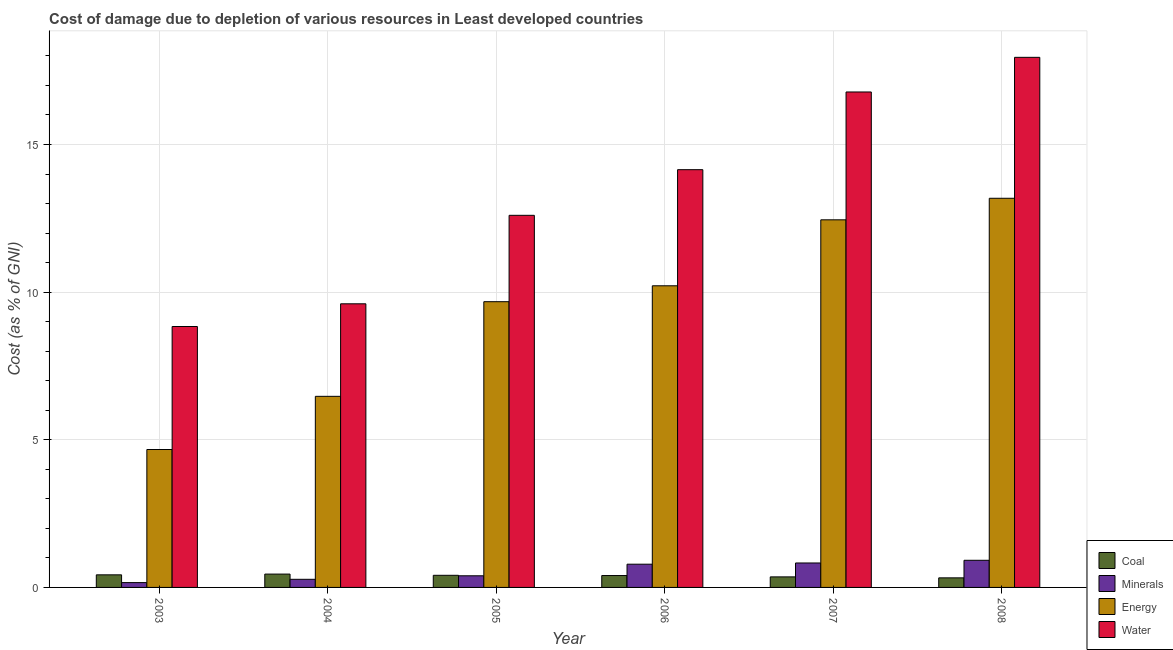How many different coloured bars are there?
Offer a very short reply. 4. What is the cost of damage due to depletion of coal in 2004?
Give a very brief answer. 0.45. Across all years, what is the maximum cost of damage due to depletion of energy?
Keep it short and to the point. 13.18. Across all years, what is the minimum cost of damage due to depletion of water?
Offer a very short reply. 8.84. In which year was the cost of damage due to depletion of minerals maximum?
Your answer should be compact. 2008. In which year was the cost of damage due to depletion of energy minimum?
Offer a terse response. 2003. What is the total cost of damage due to depletion of water in the graph?
Your answer should be compact. 79.92. What is the difference between the cost of damage due to depletion of water in 2003 and that in 2006?
Keep it short and to the point. -5.31. What is the difference between the cost of damage due to depletion of coal in 2008 and the cost of damage due to depletion of energy in 2006?
Provide a succinct answer. -0.08. What is the average cost of damage due to depletion of coal per year?
Ensure brevity in your answer.  0.4. What is the ratio of the cost of damage due to depletion of water in 2003 to that in 2005?
Your response must be concise. 0.7. Is the difference between the cost of damage due to depletion of water in 2004 and 2005 greater than the difference between the cost of damage due to depletion of coal in 2004 and 2005?
Keep it short and to the point. No. What is the difference between the highest and the second highest cost of damage due to depletion of coal?
Provide a succinct answer. 0.03. What is the difference between the highest and the lowest cost of damage due to depletion of coal?
Provide a succinct answer. 0.13. In how many years, is the cost of damage due to depletion of energy greater than the average cost of damage due to depletion of energy taken over all years?
Provide a short and direct response. 4. What does the 1st bar from the left in 2008 represents?
Offer a very short reply. Coal. What does the 2nd bar from the right in 2007 represents?
Make the answer very short. Energy. Is it the case that in every year, the sum of the cost of damage due to depletion of coal and cost of damage due to depletion of minerals is greater than the cost of damage due to depletion of energy?
Your answer should be compact. No. How many years are there in the graph?
Give a very brief answer. 6. Are the values on the major ticks of Y-axis written in scientific E-notation?
Keep it short and to the point. No. Where does the legend appear in the graph?
Offer a very short reply. Bottom right. How many legend labels are there?
Your answer should be very brief. 4. How are the legend labels stacked?
Ensure brevity in your answer.  Vertical. What is the title of the graph?
Your response must be concise. Cost of damage due to depletion of various resources in Least developed countries . What is the label or title of the X-axis?
Ensure brevity in your answer.  Year. What is the label or title of the Y-axis?
Ensure brevity in your answer.  Cost (as % of GNI). What is the Cost (as % of GNI) in Coal in 2003?
Provide a succinct answer. 0.43. What is the Cost (as % of GNI) of Minerals in 2003?
Your response must be concise. 0.16. What is the Cost (as % of GNI) of Energy in 2003?
Make the answer very short. 4.67. What is the Cost (as % of GNI) of Water in 2003?
Provide a succinct answer. 8.84. What is the Cost (as % of GNI) of Coal in 2004?
Offer a terse response. 0.45. What is the Cost (as % of GNI) of Minerals in 2004?
Keep it short and to the point. 0.27. What is the Cost (as % of GNI) of Energy in 2004?
Your answer should be compact. 6.47. What is the Cost (as % of GNI) in Water in 2004?
Offer a terse response. 9.61. What is the Cost (as % of GNI) in Coal in 2005?
Ensure brevity in your answer.  0.41. What is the Cost (as % of GNI) in Minerals in 2005?
Offer a terse response. 0.39. What is the Cost (as % of GNI) in Energy in 2005?
Ensure brevity in your answer.  9.68. What is the Cost (as % of GNI) in Water in 2005?
Give a very brief answer. 12.6. What is the Cost (as % of GNI) in Coal in 2006?
Offer a terse response. 0.4. What is the Cost (as % of GNI) of Minerals in 2006?
Offer a very short reply. 0.79. What is the Cost (as % of GNI) in Energy in 2006?
Your response must be concise. 10.22. What is the Cost (as % of GNI) in Water in 2006?
Your response must be concise. 14.15. What is the Cost (as % of GNI) of Coal in 2007?
Provide a short and direct response. 0.36. What is the Cost (as % of GNI) in Minerals in 2007?
Give a very brief answer. 0.83. What is the Cost (as % of GNI) of Energy in 2007?
Ensure brevity in your answer.  12.45. What is the Cost (as % of GNI) in Water in 2007?
Offer a very short reply. 16.78. What is the Cost (as % of GNI) in Coal in 2008?
Keep it short and to the point. 0.32. What is the Cost (as % of GNI) in Minerals in 2008?
Give a very brief answer. 0.92. What is the Cost (as % of GNI) in Energy in 2008?
Make the answer very short. 13.18. What is the Cost (as % of GNI) in Water in 2008?
Offer a terse response. 17.95. Across all years, what is the maximum Cost (as % of GNI) in Coal?
Your answer should be compact. 0.45. Across all years, what is the maximum Cost (as % of GNI) in Minerals?
Keep it short and to the point. 0.92. Across all years, what is the maximum Cost (as % of GNI) of Energy?
Your response must be concise. 13.18. Across all years, what is the maximum Cost (as % of GNI) in Water?
Offer a terse response. 17.95. Across all years, what is the minimum Cost (as % of GNI) of Coal?
Your answer should be compact. 0.32. Across all years, what is the minimum Cost (as % of GNI) of Minerals?
Offer a terse response. 0.16. Across all years, what is the minimum Cost (as % of GNI) in Energy?
Give a very brief answer. 4.67. Across all years, what is the minimum Cost (as % of GNI) in Water?
Your answer should be compact. 8.84. What is the total Cost (as % of GNI) of Coal in the graph?
Offer a terse response. 2.37. What is the total Cost (as % of GNI) of Minerals in the graph?
Your response must be concise. 3.37. What is the total Cost (as % of GNI) in Energy in the graph?
Your answer should be compact. 56.66. What is the total Cost (as % of GNI) in Water in the graph?
Your answer should be very brief. 79.92. What is the difference between the Cost (as % of GNI) in Coal in 2003 and that in 2004?
Your response must be concise. -0.03. What is the difference between the Cost (as % of GNI) of Minerals in 2003 and that in 2004?
Your answer should be compact. -0.11. What is the difference between the Cost (as % of GNI) in Energy in 2003 and that in 2004?
Make the answer very short. -1.8. What is the difference between the Cost (as % of GNI) in Water in 2003 and that in 2004?
Ensure brevity in your answer.  -0.77. What is the difference between the Cost (as % of GNI) of Coal in 2003 and that in 2005?
Offer a terse response. 0.02. What is the difference between the Cost (as % of GNI) of Minerals in 2003 and that in 2005?
Your response must be concise. -0.23. What is the difference between the Cost (as % of GNI) in Energy in 2003 and that in 2005?
Provide a short and direct response. -5.01. What is the difference between the Cost (as % of GNI) of Water in 2003 and that in 2005?
Keep it short and to the point. -3.77. What is the difference between the Cost (as % of GNI) in Coal in 2003 and that in 2006?
Give a very brief answer. 0.02. What is the difference between the Cost (as % of GNI) in Minerals in 2003 and that in 2006?
Your answer should be compact. -0.62. What is the difference between the Cost (as % of GNI) in Energy in 2003 and that in 2006?
Your answer should be compact. -5.54. What is the difference between the Cost (as % of GNI) in Water in 2003 and that in 2006?
Offer a terse response. -5.31. What is the difference between the Cost (as % of GNI) of Coal in 2003 and that in 2007?
Your response must be concise. 0.07. What is the difference between the Cost (as % of GNI) in Minerals in 2003 and that in 2007?
Provide a short and direct response. -0.66. What is the difference between the Cost (as % of GNI) in Energy in 2003 and that in 2007?
Provide a short and direct response. -7.78. What is the difference between the Cost (as % of GNI) of Water in 2003 and that in 2007?
Offer a terse response. -7.94. What is the difference between the Cost (as % of GNI) of Coal in 2003 and that in 2008?
Offer a very short reply. 0.1. What is the difference between the Cost (as % of GNI) of Minerals in 2003 and that in 2008?
Make the answer very short. -0.76. What is the difference between the Cost (as % of GNI) in Energy in 2003 and that in 2008?
Keep it short and to the point. -8.51. What is the difference between the Cost (as % of GNI) in Water in 2003 and that in 2008?
Make the answer very short. -9.12. What is the difference between the Cost (as % of GNI) of Coal in 2004 and that in 2005?
Offer a very short reply. 0.04. What is the difference between the Cost (as % of GNI) in Minerals in 2004 and that in 2005?
Make the answer very short. -0.12. What is the difference between the Cost (as % of GNI) of Energy in 2004 and that in 2005?
Your answer should be very brief. -3.21. What is the difference between the Cost (as % of GNI) in Water in 2004 and that in 2005?
Your answer should be compact. -3. What is the difference between the Cost (as % of GNI) in Coal in 2004 and that in 2006?
Offer a very short reply. 0.05. What is the difference between the Cost (as % of GNI) in Minerals in 2004 and that in 2006?
Your answer should be compact. -0.51. What is the difference between the Cost (as % of GNI) of Energy in 2004 and that in 2006?
Make the answer very short. -3.74. What is the difference between the Cost (as % of GNI) in Water in 2004 and that in 2006?
Your response must be concise. -4.54. What is the difference between the Cost (as % of GNI) in Coal in 2004 and that in 2007?
Keep it short and to the point. 0.09. What is the difference between the Cost (as % of GNI) of Minerals in 2004 and that in 2007?
Your response must be concise. -0.55. What is the difference between the Cost (as % of GNI) in Energy in 2004 and that in 2007?
Give a very brief answer. -5.98. What is the difference between the Cost (as % of GNI) in Water in 2004 and that in 2007?
Provide a succinct answer. -7.17. What is the difference between the Cost (as % of GNI) of Coal in 2004 and that in 2008?
Offer a terse response. 0.13. What is the difference between the Cost (as % of GNI) in Minerals in 2004 and that in 2008?
Your response must be concise. -0.64. What is the difference between the Cost (as % of GNI) in Energy in 2004 and that in 2008?
Provide a succinct answer. -6.71. What is the difference between the Cost (as % of GNI) of Water in 2004 and that in 2008?
Make the answer very short. -8.35. What is the difference between the Cost (as % of GNI) in Coal in 2005 and that in 2006?
Your answer should be very brief. 0.01. What is the difference between the Cost (as % of GNI) of Minerals in 2005 and that in 2006?
Ensure brevity in your answer.  -0.39. What is the difference between the Cost (as % of GNI) of Energy in 2005 and that in 2006?
Your answer should be very brief. -0.54. What is the difference between the Cost (as % of GNI) of Water in 2005 and that in 2006?
Provide a succinct answer. -1.55. What is the difference between the Cost (as % of GNI) in Coal in 2005 and that in 2007?
Your response must be concise. 0.05. What is the difference between the Cost (as % of GNI) in Minerals in 2005 and that in 2007?
Your response must be concise. -0.43. What is the difference between the Cost (as % of GNI) in Energy in 2005 and that in 2007?
Offer a very short reply. -2.77. What is the difference between the Cost (as % of GNI) of Water in 2005 and that in 2007?
Make the answer very short. -4.18. What is the difference between the Cost (as % of GNI) of Coal in 2005 and that in 2008?
Make the answer very short. 0.09. What is the difference between the Cost (as % of GNI) in Minerals in 2005 and that in 2008?
Your answer should be very brief. -0.53. What is the difference between the Cost (as % of GNI) of Energy in 2005 and that in 2008?
Ensure brevity in your answer.  -3.5. What is the difference between the Cost (as % of GNI) of Water in 2005 and that in 2008?
Your answer should be very brief. -5.35. What is the difference between the Cost (as % of GNI) in Coal in 2006 and that in 2007?
Provide a short and direct response. 0.05. What is the difference between the Cost (as % of GNI) in Minerals in 2006 and that in 2007?
Provide a short and direct response. -0.04. What is the difference between the Cost (as % of GNI) in Energy in 2006 and that in 2007?
Give a very brief answer. -2.23. What is the difference between the Cost (as % of GNI) in Water in 2006 and that in 2007?
Ensure brevity in your answer.  -2.63. What is the difference between the Cost (as % of GNI) in Coal in 2006 and that in 2008?
Your answer should be very brief. 0.08. What is the difference between the Cost (as % of GNI) of Minerals in 2006 and that in 2008?
Ensure brevity in your answer.  -0.13. What is the difference between the Cost (as % of GNI) of Energy in 2006 and that in 2008?
Offer a very short reply. -2.96. What is the difference between the Cost (as % of GNI) in Water in 2006 and that in 2008?
Provide a short and direct response. -3.81. What is the difference between the Cost (as % of GNI) in Coal in 2007 and that in 2008?
Your answer should be compact. 0.03. What is the difference between the Cost (as % of GNI) of Minerals in 2007 and that in 2008?
Offer a terse response. -0.09. What is the difference between the Cost (as % of GNI) in Energy in 2007 and that in 2008?
Keep it short and to the point. -0.73. What is the difference between the Cost (as % of GNI) in Water in 2007 and that in 2008?
Make the answer very short. -1.17. What is the difference between the Cost (as % of GNI) of Coal in 2003 and the Cost (as % of GNI) of Minerals in 2004?
Make the answer very short. 0.15. What is the difference between the Cost (as % of GNI) of Coal in 2003 and the Cost (as % of GNI) of Energy in 2004?
Provide a succinct answer. -6.05. What is the difference between the Cost (as % of GNI) of Coal in 2003 and the Cost (as % of GNI) of Water in 2004?
Provide a succinct answer. -9.18. What is the difference between the Cost (as % of GNI) of Minerals in 2003 and the Cost (as % of GNI) of Energy in 2004?
Your response must be concise. -6.31. What is the difference between the Cost (as % of GNI) of Minerals in 2003 and the Cost (as % of GNI) of Water in 2004?
Ensure brevity in your answer.  -9.44. What is the difference between the Cost (as % of GNI) in Energy in 2003 and the Cost (as % of GNI) in Water in 2004?
Offer a very short reply. -4.93. What is the difference between the Cost (as % of GNI) of Coal in 2003 and the Cost (as % of GNI) of Minerals in 2005?
Your response must be concise. 0.03. What is the difference between the Cost (as % of GNI) in Coal in 2003 and the Cost (as % of GNI) in Energy in 2005?
Offer a terse response. -9.25. What is the difference between the Cost (as % of GNI) in Coal in 2003 and the Cost (as % of GNI) in Water in 2005?
Your answer should be very brief. -12.18. What is the difference between the Cost (as % of GNI) in Minerals in 2003 and the Cost (as % of GNI) in Energy in 2005?
Your response must be concise. -9.51. What is the difference between the Cost (as % of GNI) in Minerals in 2003 and the Cost (as % of GNI) in Water in 2005?
Keep it short and to the point. -12.44. What is the difference between the Cost (as % of GNI) of Energy in 2003 and the Cost (as % of GNI) of Water in 2005?
Provide a short and direct response. -7.93. What is the difference between the Cost (as % of GNI) of Coal in 2003 and the Cost (as % of GNI) of Minerals in 2006?
Your response must be concise. -0.36. What is the difference between the Cost (as % of GNI) in Coal in 2003 and the Cost (as % of GNI) in Energy in 2006?
Offer a very short reply. -9.79. What is the difference between the Cost (as % of GNI) in Coal in 2003 and the Cost (as % of GNI) in Water in 2006?
Ensure brevity in your answer.  -13.72. What is the difference between the Cost (as % of GNI) of Minerals in 2003 and the Cost (as % of GNI) of Energy in 2006?
Your response must be concise. -10.05. What is the difference between the Cost (as % of GNI) in Minerals in 2003 and the Cost (as % of GNI) in Water in 2006?
Your answer should be very brief. -13.98. What is the difference between the Cost (as % of GNI) in Energy in 2003 and the Cost (as % of GNI) in Water in 2006?
Make the answer very short. -9.48. What is the difference between the Cost (as % of GNI) of Coal in 2003 and the Cost (as % of GNI) of Minerals in 2007?
Your answer should be compact. -0.4. What is the difference between the Cost (as % of GNI) of Coal in 2003 and the Cost (as % of GNI) of Energy in 2007?
Give a very brief answer. -12.02. What is the difference between the Cost (as % of GNI) in Coal in 2003 and the Cost (as % of GNI) in Water in 2007?
Your answer should be compact. -16.35. What is the difference between the Cost (as % of GNI) in Minerals in 2003 and the Cost (as % of GNI) in Energy in 2007?
Provide a succinct answer. -12.29. What is the difference between the Cost (as % of GNI) in Minerals in 2003 and the Cost (as % of GNI) in Water in 2007?
Make the answer very short. -16.62. What is the difference between the Cost (as % of GNI) of Energy in 2003 and the Cost (as % of GNI) of Water in 2007?
Offer a very short reply. -12.11. What is the difference between the Cost (as % of GNI) of Coal in 2003 and the Cost (as % of GNI) of Minerals in 2008?
Provide a succinct answer. -0.49. What is the difference between the Cost (as % of GNI) in Coal in 2003 and the Cost (as % of GNI) in Energy in 2008?
Offer a very short reply. -12.75. What is the difference between the Cost (as % of GNI) in Coal in 2003 and the Cost (as % of GNI) in Water in 2008?
Offer a very short reply. -17.53. What is the difference between the Cost (as % of GNI) of Minerals in 2003 and the Cost (as % of GNI) of Energy in 2008?
Your answer should be compact. -13.02. What is the difference between the Cost (as % of GNI) of Minerals in 2003 and the Cost (as % of GNI) of Water in 2008?
Offer a terse response. -17.79. What is the difference between the Cost (as % of GNI) of Energy in 2003 and the Cost (as % of GNI) of Water in 2008?
Provide a short and direct response. -13.28. What is the difference between the Cost (as % of GNI) of Coal in 2004 and the Cost (as % of GNI) of Minerals in 2005?
Keep it short and to the point. 0.06. What is the difference between the Cost (as % of GNI) in Coal in 2004 and the Cost (as % of GNI) in Energy in 2005?
Provide a succinct answer. -9.23. What is the difference between the Cost (as % of GNI) in Coal in 2004 and the Cost (as % of GNI) in Water in 2005?
Give a very brief answer. -12.15. What is the difference between the Cost (as % of GNI) of Minerals in 2004 and the Cost (as % of GNI) of Energy in 2005?
Your response must be concise. -9.4. What is the difference between the Cost (as % of GNI) of Minerals in 2004 and the Cost (as % of GNI) of Water in 2005?
Make the answer very short. -12.33. What is the difference between the Cost (as % of GNI) of Energy in 2004 and the Cost (as % of GNI) of Water in 2005?
Ensure brevity in your answer.  -6.13. What is the difference between the Cost (as % of GNI) of Coal in 2004 and the Cost (as % of GNI) of Minerals in 2006?
Keep it short and to the point. -0.33. What is the difference between the Cost (as % of GNI) in Coal in 2004 and the Cost (as % of GNI) in Energy in 2006?
Your answer should be very brief. -9.76. What is the difference between the Cost (as % of GNI) of Coal in 2004 and the Cost (as % of GNI) of Water in 2006?
Provide a succinct answer. -13.7. What is the difference between the Cost (as % of GNI) in Minerals in 2004 and the Cost (as % of GNI) in Energy in 2006?
Make the answer very short. -9.94. What is the difference between the Cost (as % of GNI) in Minerals in 2004 and the Cost (as % of GNI) in Water in 2006?
Ensure brevity in your answer.  -13.87. What is the difference between the Cost (as % of GNI) of Energy in 2004 and the Cost (as % of GNI) of Water in 2006?
Give a very brief answer. -7.68. What is the difference between the Cost (as % of GNI) of Coal in 2004 and the Cost (as % of GNI) of Minerals in 2007?
Ensure brevity in your answer.  -0.38. What is the difference between the Cost (as % of GNI) in Coal in 2004 and the Cost (as % of GNI) in Energy in 2007?
Give a very brief answer. -12. What is the difference between the Cost (as % of GNI) of Coal in 2004 and the Cost (as % of GNI) of Water in 2007?
Give a very brief answer. -16.33. What is the difference between the Cost (as % of GNI) in Minerals in 2004 and the Cost (as % of GNI) in Energy in 2007?
Offer a terse response. -12.17. What is the difference between the Cost (as % of GNI) in Minerals in 2004 and the Cost (as % of GNI) in Water in 2007?
Provide a succinct answer. -16.5. What is the difference between the Cost (as % of GNI) of Energy in 2004 and the Cost (as % of GNI) of Water in 2007?
Give a very brief answer. -10.31. What is the difference between the Cost (as % of GNI) in Coal in 2004 and the Cost (as % of GNI) in Minerals in 2008?
Offer a terse response. -0.47. What is the difference between the Cost (as % of GNI) of Coal in 2004 and the Cost (as % of GNI) of Energy in 2008?
Your response must be concise. -12.73. What is the difference between the Cost (as % of GNI) of Coal in 2004 and the Cost (as % of GNI) of Water in 2008?
Keep it short and to the point. -17.5. What is the difference between the Cost (as % of GNI) of Minerals in 2004 and the Cost (as % of GNI) of Energy in 2008?
Your response must be concise. -12.9. What is the difference between the Cost (as % of GNI) in Minerals in 2004 and the Cost (as % of GNI) in Water in 2008?
Provide a short and direct response. -17.68. What is the difference between the Cost (as % of GNI) in Energy in 2004 and the Cost (as % of GNI) in Water in 2008?
Offer a terse response. -11.48. What is the difference between the Cost (as % of GNI) of Coal in 2005 and the Cost (as % of GNI) of Minerals in 2006?
Your response must be concise. -0.38. What is the difference between the Cost (as % of GNI) of Coal in 2005 and the Cost (as % of GNI) of Energy in 2006?
Keep it short and to the point. -9.81. What is the difference between the Cost (as % of GNI) of Coal in 2005 and the Cost (as % of GNI) of Water in 2006?
Your answer should be compact. -13.74. What is the difference between the Cost (as % of GNI) of Minerals in 2005 and the Cost (as % of GNI) of Energy in 2006?
Keep it short and to the point. -9.82. What is the difference between the Cost (as % of GNI) of Minerals in 2005 and the Cost (as % of GNI) of Water in 2006?
Keep it short and to the point. -13.75. What is the difference between the Cost (as % of GNI) of Energy in 2005 and the Cost (as % of GNI) of Water in 2006?
Make the answer very short. -4.47. What is the difference between the Cost (as % of GNI) of Coal in 2005 and the Cost (as % of GNI) of Minerals in 2007?
Keep it short and to the point. -0.42. What is the difference between the Cost (as % of GNI) of Coal in 2005 and the Cost (as % of GNI) of Energy in 2007?
Ensure brevity in your answer.  -12.04. What is the difference between the Cost (as % of GNI) in Coal in 2005 and the Cost (as % of GNI) in Water in 2007?
Give a very brief answer. -16.37. What is the difference between the Cost (as % of GNI) in Minerals in 2005 and the Cost (as % of GNI) in Energy in 2007?
Provide a succinct answer. -12.06. What is the difference between the Cost (as % of GNI) in Minerals in 2005 and the Cost (as % of GNI) in Water in 2007?
Make the answer very short. -16.39. What is the difference between the Cost (as % of GNI) of Energy in 2005 and the Cost (as % of GNI) of Water in 2007?
Offer a very short reply. -7.1. What is the difference between the Cost (as % of GNI) of Coal in 2005 and the Cost (as % of GNI) of Minerals in 2008?
Provide a short and direct response. -0.51. What is the difference between the Cost (as % of GNI) of Coal in 2005 and the Cost (as % of GNI) of Energy in 2008?
Your response must be concise. -12.77. What is the difference between the Cost (as % of GNI) in Coal in 2005 and the Cost (as % of GNI) in Water in 2008?
Offer a very short reply. -17.54. What is the difference between the Cost (as % of GNI) in Minerals in 2005 and the Cost (as % of GNI) in Energy in 2008?
Provide a succinct answer. -12.79. What is the difference between the Cost (as % of GNI) in Minerals in 2005 and the Cost (as % of GNI) in Water in 2008?
Provide a short and direct response. -17.56. What is the difference between the Cost (as % of GNI) of Energy in 2005 and the Cost (as % of GNI) of Water in 2008?
Your answer should be compact. -8.28. What is the difference between the Cost (as % of GNI) of Coal in 2006 and the Cost (as % of GNI) of Minerals in 2007?
Your response must be concise. -0.43. What is the difference between the Cost (as % of GNI) in Coal in 2006 and the Cost (as % of GNI) in Energy in 2007?
Offer a very short reply. -12.05. What is the difference between the Cost (as % of GNI) in Coal in 2006 and the Cost (as % of GNI) in Water in 2007?
Your answer should be very brief. -16.38. What is the difference between the Cost (as % of GNI) in Minerals in 2006 and the Cost (as % of GNI) in Energy in 2007?
Make the answer very short. -11.66. What is the difference between the Cost (as % of GNI) of Minerals in 2006 and the Cost (as % of GNI) of Water in 2007?
Provide a succinct answer. -15.99. What is the difference between the Cost (as % of GNI) of Energy in 2006 and the Cost (as % of GNI) of Water in 2007?
Your response must be concise. -6.56. What is the difference between the Cost (as % of GNI) in Coal in 2006 and the Cost (as % of GNI) in Minerals in 2008?
Offer a very short reply. -0.52. What is the difference between the Cost (as % of GNI) in Coal in 2006 and the Cost (as % of GNI) in Energy in 2008?
Offer a very short reply. -12.78. What is the difference between the Cost (as % of GNI) in Coal in 2006 and the Cost (as % of GNI) in Water in 2008?
Your answer should be very brief. -17.55. What is the difference between the Cost (as % of GNI) of Minerals in 2006 and the Cost (as % of GNI) of Energy in 2008?
Provide a short and direct response. -12.39. What is the difference between the Cost (as % of GNI) in Minerals in 2006 and the Cost (as % of GNI) in Water in 2008?
Your answer should be very brief. -17.17. What is the difference between the Cost (as % of GNI) in Energy in 2006 and the Cost (as % of GNI) in Water in 2008?
Ensure brevity in your answer.  -7.74. What is the difference between the Cost (as % of GNI) in Coal in 2007 and the Cost (as % of GNI) in Minerals in 2008?
Your response must be concise. -0.56. What is the difference between the Cost (as % of GNI) in Coal in 2007 and the Cost (as % of GNI) in Energy in 2008?
Your response must be concise. -12.82. What is the difference between the Cost (as % of GNI) of Coal in 2007 and the Cost (as % of GNI) of Water in 2008?
Offer a terse response. -17.6. What is the difference between the Cost (as % of GNI) in Minerals in 2007 and the Cost (as % of GNI) in Energy in 2008?
Your response must be concise. -12.35. What is the difference between the Cost (as % of GNI) of Minerals in 2007 and the Cost (as % of GNI) of Water in 2008?
Your response must be concise. -17.12. What is the difference between the Cost (as % of GNI) of Energy in 2007 and the Cost (as % of GNI) of Water in 2008?
Make the answer very short. -5.5. What is the average Cost (as % of GNI) in Coal per year?
Your answer should be compact. 0.4. What is the average Cost (as % of GNI) of Minerals per year?
Offer a terse response. 0.56. What is the average Cost (as % of GNI) in Energy per year?
Give a very brief answer. 9.44. What is the average Cost (as % of GNI) of Water per year?
Your answer should be compact. 13.32. In the year 2003, what is the difference between the Cost (as % of GNI) of Coal and Cost (as % of GNI) of Minerals?
Ensure brevity in your answer.  0.26. In the year 2003, what is the difference between the Cost (as % of GNI) of Coal and Cost (as % of GNI) of Energy?
Provide a succinct answer. -4.24. In the year 2003, what is the difference between the Cost (as % of GNI) of Coal and Cost (as % of GNI) of Water?
Provide a succinct answer. -8.41. In the year 2003, what is the difference between the Cost (as % of GNI) of Minerals and Cost (as % of GNI) of Energy?
Your answer should be very brief. -4.51. In the year 2003, what is the difference between the Cost (as % of GNI) of Minerals and Cost (as % of GNI) of Water?
Offer a terse response. -8.67. In the year 2003, what is the difference between the Cost (as % of GNI) in Energy and Cost (as % of GNI) in Water?
Give a very brief answer. -4.17. In the year 2004, what is the difference between the Cost (as % of GNI) of Coal and Cost (as % of GNI) of Minerals?
Give a very brief answer. 0.18. In the year 2004, what is the difference between the Cost (as % of GNI) in Coal and Cost (as % of GNI) in Energy?
Your answer should be very brief. -6.02. In the year 2004, what is the difference between the Cost (as % of GNI) in Coal and Cost (as % of GNI) in Water?
Ensure brevity in your answer.  -9.15. In the year 2004, what is the difference between the Cost (as % of GNI) in Minerals and Cost (as % of GNI) in Energy?
Make the answer very short. -6.2. In the year 2004, what is the difference between the Cost (as % of GNI) in Minerals and Cost (as % of GNI) in Water?
Ensure brevity in your answer.  -9.33. In the year 2004, what is the difference between the Cost (as % of GNI) of Energy and Cost (as % of GNI) of Water?
Provide a short and direct response. -3.13. In the year 2005, what is the difference between the Cost (as % of GNI) in Coal and Cost (as % of GNI) in Minerals?
Make the answer very short. 0.02. In the year 2005, what is the difference between the Cost (as % of GNI) in Coal and Cost (as % of GNI) in Energy?
Provide a succinct answer. -9.27. In the year 2005, what is the difference between the Cost (as % of GNI) in Coal and Cost (as % of GNI) in Water?
Provide a succinct answer. -12.19. In the year 2005, what is the difference between the Cost (as % of GNI) of Minerals and Cost (as % of GNI) of Energy?
Offer a terse response. -9.28. In the year 2005, what is the difference between the Cost (as % of GNI) in Minerals and Cost (as % of GNI) in Water?
Make the answer very short. -12.21. In the year 2005, what is the difference between the Cost (as % of GNI) of Energy and Cost (as % of GNI) of Water?
Your answer should be very brief. -2.92. In the year 2006, what is the difference between the Cost (as % of GNI) in Coal and Cost (as % of GNI) in Minerals?
Provide a succinct answer. -0.38. In the year 2006, what is the difference between the Cost (as % of GNI) in Coal and Cost (as % of GNI) in Energy?
Your answer should be compact. -9.81. In the year 2006, what is the difference between the Cost (as % of GNI) in Coal and Cost (as % of GNI) in Water?
Ensure brevity in your answer.  -13.75. In the year 2006, what is the difference between the Cost (as % of GNI) of Minerals and Cost (as % of GNI) of Energy?
Your answer should be very brief. -9.43. In the year 2006, what is the difference between the Cost (as % of GNI) in Minerals and Cost (as % of GNI) in Water?
Provide a short and direct response. -13.36. In the year 2006, what is the difference between the Cost (as % of GNI) of Energy and Cost (as % of GNI) of Water?
Your answer should be very brief. -3.93. In the year 2007, what is the difference between the Cost (as % of GNI) in Coal and Cost (as % of GNI) in Minerals?
Your answer should be very brief. -0.47. In the year 2007, what is the difference between the Cost (as % of GNI) in Coal and Cost (as % of GNI) in Energy?
Ensure brevity in your answer.  -12.09. In the year 2007, what is the difference between the Cost (as % of GNI) in Coal and Cost (as % of GNI) in Water?
Provide a short and direct response. -16.42. In the year 2007, what is the difference between the Cost (as % of GNI) in Minerals and Cost (as % of GNI) in Energy?
Make the answer very short. -11.62. In the year 2007, what is the difference between the Cost (as % of GNI) of Minerals and Cost (as % of GNI) of Water?
Ensure brevity in your answer.  -15.95. In the year 2007, what is the difference between the Cost (as % of GNI) in Energy and Cost (as % of GNI) in Water?
Keep it short and to the point. -4.33. In the year 2008, what is the difference between the Cost (as % of GNI) in Coal and Cost (as % of GNI) in Minerals?
Provide a short and direct response. -0.59. In the year 2008, what is the difference between the Cost (as % of GNI) in Coal and Cost (as % of GNI) in Energy?
Your response must be concise. -12.86. In the year 2008, what is the difference between the Cost (as % of GNI) in Coal and Cost (as % of GNI) in Water?
Keep it short and to the point. -17.63. In the year 2008, what is the difference between the Cost (as % of GNI) in Minerals and Cost (as % of GNI) in Energy?
Keep it short and to the point. -12.26. In the year 2008, what is the difference between the Cost (as % of GNI) of Minerals and Cost (as % of GNI) of Water?
Your answer should be compact. -17.03. In the year 2008, what is the difference between the Cost (as % of GNI) in Energy and Cost (as % of GNI) in Water?
Give a very brief answer. -4.77. What is the ratio of the Cost (as % of GNI) of Coal in 2003 to that in 2004?
Offer a very short reply. 0.94. What is the ratio of the Cost (as % of GNI) of Minerals in 2003 to that in 2004?
Your answer should be compact. 0.59. What is the ratio of the Cost (as % of GNI) in Energy in 2003 to that in 2004?
Make the answer very short. 0.72. What is the ratio of the Cost (as % of GNI) in Water in 2003 to that in 2004?
Your response must be concise. 0.92. What is the ratio of the Cost (as % of GNI) of Coal in 2003 to that in 2005?
Make the answer very short. 1.04. What is the ratio of the Cost (as % of GNI) of Minerals in 2003 to that in 2005?
Keep it short and to the point. 0.41. What is the ratio of the Cost (as % of GNI) in Energy in 2003 to that in 2005?
Keep it short and to the point. 0.48. What is the ratio of the Cost (as % of GNI) of Water in 2003 to that in 2005?
Ensure brevity in your answer.  0.7. What is the ratio of the Cost (as % of GNI) of Coal in 2003 to that in 2006?
Ensure brevity in your answer.  1.06. What is the ratio of the Cost (as % of GNI) in Minerals in 2003 to that in 2006?
Make the answer very short. 0.21. What is the ratio of the Cost (as % of GNI) of Energy in 2003 to that in 2006?
Provide a short and direct response. 0.46. What is the ratio of the Cost (as % of GNI) in Water in 2003 to that in 2006?
Your answer should be very brief. 0.62. What is the ratio of the Cost (as % of GNI) in Coal in 2003 to that in 2007?
Keep it short and to the point. 1.19. What is the ratio of the Cost (as % of GNI) of Minerals in 2003 to that in 2007?
Your response must be concise. 0.2. What is the ratio of the Cost (as % of GNI) of Energy in 2003 to that in 2007?
Offer a very short reply. 0.38. What is the ratio of the Cost (as % of GNI) in Water in 2003 to that in 2007?
Your answer should be compact. 0.53. What is the ratio of the Cost (as % of GNI) of Coal in 2003 to that in 2008?
Keep it short and to the point. 1.32. What is the ratio of the Cost (as % of GNI) of Minerals in 2003 to that in 2008?
Your response must be concise. 0.18. What is the ratio of the Cost (as % of GNI) in Energy in 2003 to that in 2008?
Your answer should be very brief. 0.35. What is the ratio of the Cost (as % of GNI) in Water in 2003 to that in 2008?
Offer a terse response. 0.49. What is the ratio of the Cost (as % of GNI) in Coal in 2004 to that in 2005?
Your response must be concise. 1.1. What is the ratio of the Cost (as % of GNI) of Minerals in 2004 to that in 2005?
Keep it short and to the point. 0.7. What is the ratio of the Cost (as % of GNI) of Energy in 2004 to that in 2005?
Offer a terse response. 0.67. What is the ratio of the Cost (as % of GNI) in Water in 2004 to that in 2005?
Your response must be concise. 0.76. What is the ratio of the Cost (as % of GNI) of Coal in 2004 to that in 2006?
Offer a very short reply. 1.12. What is the ratio of the Cost (as % of GNI) in Minerals in 2004 to that in 2006?
Make the answer very short. 0.35. What is the ratio of the Cost (as % of GNI) in Energy in 2004 to that in 2006?
Provide a succinct answer. 0.63. What is the ratio of the Cost (as % of GNI) of Water in 2004 to that in 2006?
Your answer should be compact. 0.68. What is the ratio of the Cost (as % of GNI) of Coal in 2004 to that in 2007?
Offer a very short reply. 1.27. What is the ratio of the Cost (as % of GNI) of Minerals in 2004 to that in 2007?
Provide a short and direct response. 0.33. What is the ratio of the Cost (as % of GNI) in Energy in 2004 to that in 2007?
Your answer should be compact. 0.52. What is the ratio of the Cost (as % of GNI) of Water in 2004 to that in 2007?
Keep it short and to the point. 0.57. What is the ratio of the Cost (as % of GNI) of Coal in 2004 to that in 2008?
Provide a succinct answer. 1.39. What is the ratio of the Cost (as % of GNI) of Minerals in 2004 to that in 2008?
Your answer should be compact. 0.3. What is the ratio of the Cost (as % of GNI) in Energy in 2004 to that in 2008?
Your answer should be compact. 0.49. What is the ratio of the Cost (as % of GNI) of Water in 2004 to that in 2008?
Your answer should be very brief. 0.54. What is the ratio of the Cost (as % of GNI) of Coal in 2005 to that in 2006?
Provide a succinct answer. 1.02. What is the ratio of the Cost (as % of GNI) of Minerals in 2005 to that in 2006?
Your answer should be compact. 0.5. What is the ratio of the Cost (as % of GNI) of Energy in 2005 to that in 2006?
Make the answer very short. 0.95. What is the ratio of the Cost (as % of GNI) in Water in 2005 to that in 2006?
Your response must be concise. 0.89. What is the ratio of the Cost (as % of GNI) in Coal in 2005 to that in 2007?
Keep it short and to the point. 1.15. What is the ratio of the Cost (as % of GNI) of Minerals in 2005 to that in 2007?
Provide a short and direct response. 0.48. What is the ratio of the Cost (as % of GNI) of Energy in 2005 to that in 2007?
Your answer should be compact. 0.78. What is the ratio of the Cost (as % of GNI) of Water in 2005 to that in 2007?
Offer a terse response. 0.75. What is the ratio of the Cost (as % of GNI) in Coal in 2005 to that in 2008?
Provide a short and direct response. 1.27. What is the ratio of the Cost (as % of GNI) in Minerals in 2005 to that in 2008?
Provide a succinct answer. 0.43. What is the ratio of the Cost (as % of GNI) in Energy in 2005 to that in 2008?
Offer a terse response. 0.73. What is the ratio of the Cost (as % of GNI) in Water in 2005 to that in 2008?
Ensure brevity in your answer.  0.7. What is the ratio of the Cost (as % of GNI) in Coal in 2006 to that in 2007?
Ensure brevity in your answer.  1.13. What is the ratio of the Cost (as % of GNI) in Energy in 2006 to that in 2007?
Your response must be concise. 0.82. What is the ratio of the Cost (as % of GNI) of Water in 2006 to that in 2007?
Your response must be concise. 0.84. What is the ratio of the Cost (as % of GNI) of Coal in 2006 to that in 2008?
Make the answer very short. 1.24. What is the ratio of the Cost (as % of GNI) of Minerals in 2006 to that in 2008?
Provide a succinct answer. 0.86. What is the ratio of the Cost (as % of GNI) in Energy in 2006 to that in 2008?
Ensure brevity in your answer.  0.78. What is the ratio of the Cost (as % of GNI) in Water in 2006 to that in 2008?
Ensure brevity in your answer.  0.79. What is the ratio of the Cost (as % of GNI) in Coal in 2007 to that in 2008?
Offer a terse response. 1.1. What is the ratio of the Cost (as % of GNI) of Minerals in 2007 to that in 2008?
Make the answer very short. 0.9. What is the ratio of the Cost (as % of GNI) of Energy in 2007 to that in 2008?
Keep it short and to the point. 0.94. What is the ratio of the Cost (as % of GNI) of Water in 2007 to that in 2008?
Keep it short and to the point. 0.93. What is the difference between the highest and the second highest Cost (as % of GNI) in Coal?
Provide a short and direct response. 0.03. What is the difference between the highest and the second highest Cost (as % of GNI) of Minerals?
Provide a succinct answer. 0.09. What is the difference between the highest and the second highest Cost (as % of GNI) in Energy?
Your answer should be very brief. 0.73. What is the difference between the highest and the second highest Cost (as % of GNI) in Water?
Offer a terse response. 1.17. What is the difference between the highest and the lowest Cost (as % of GNI) of Coal?
Ensure brevity in your answer.  0.13. What is the difference between the highest and the lowest Cost (as % of GNI) of Minerals?
Give a very brief answer. 0.76. What is the difference between the highest and the lowest Cost (as % of GNI) in Energy?
Give a very brief answer. 8.51. What is the difference between the highest and the lowest Cost (as % of GNI) of Water?
Provide a succinct answer. 9.12. 